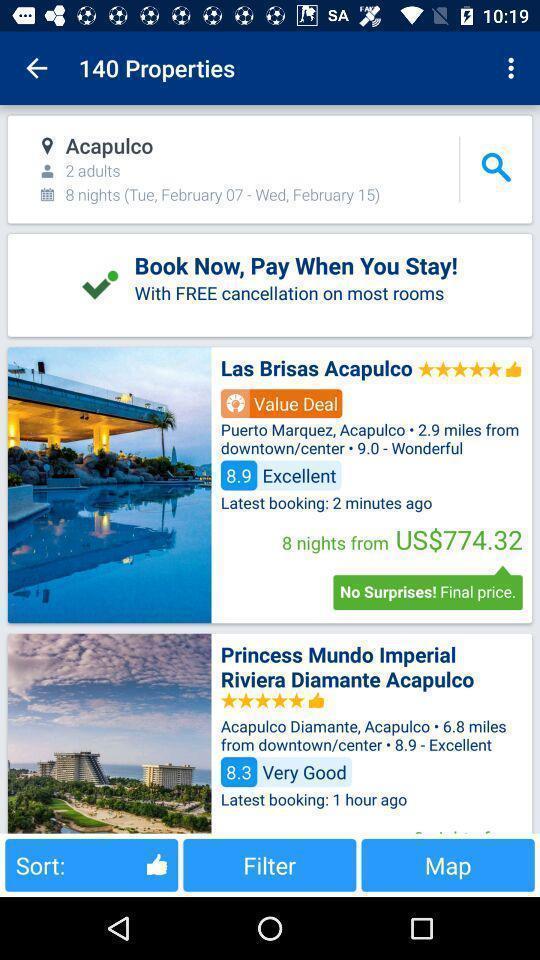Give me a narrative description of this picture. Search page for the tour app. 